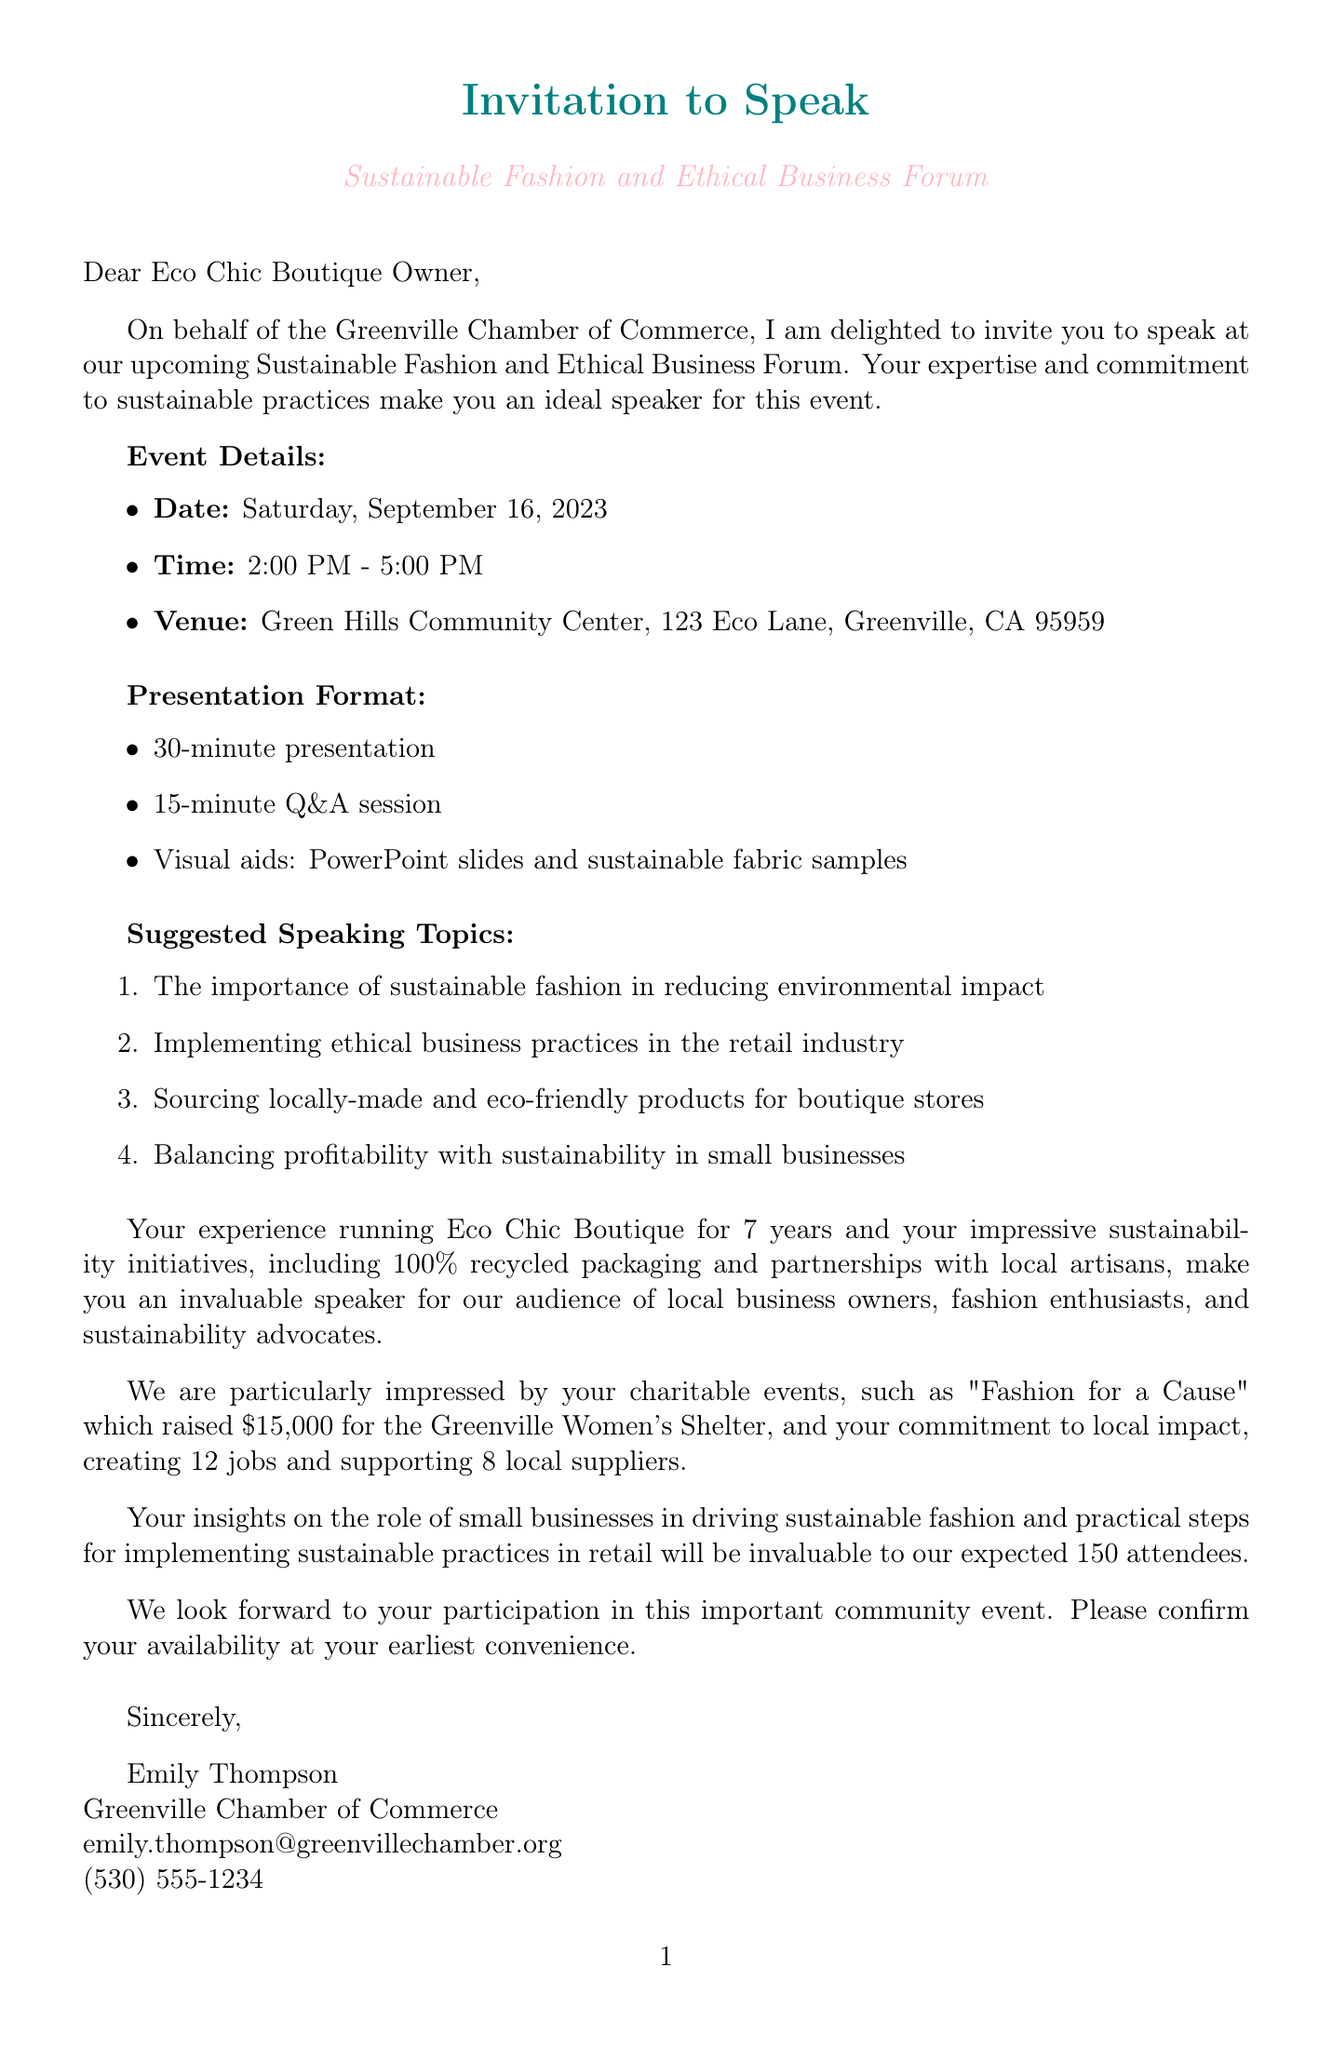What is the name of the event? The name of the event is mentioned in the document’s title as "Sustainable Fashion and Ethical Business Forum."
Answer: Sustainable Fashion and Ethical Business Forum What is the date of the event? The date of the event is specified in the event details section.
Answer: Saturday, September 16, 2023 Who is the contact person for the event? The document states that the contact person is Emily Thompson, who is associated with the organizing body.
Answer: Emily Thompson How long is the presentation? The presentation duration is mentioned in the presentation format section of the document.
Answer: 30-minute How much funds were raised for the "Fashion for a Cause"? The document provides information about the funds raised for specific charitable events, including this one.
Answer: $15,000 What is one of the suggested speaking topics? The document lists suggested speaking topics for the presentation; any of them would be a valid answer.
Answer: The importance of sustainable fashion in reducing environmental impact What is the anticipated number of attendees? The expected attendees are mentioned in the audience section of the document.
Answer: 150 How many years has Eco Chic Boutique been in business? The number of years Eco Chic Boutique has been in business is provided in the boutique credentials section.
Answer: 7 What organization is hosting the event? The organizing body is specifically mentioned in the document as the host of the event.
Answer: Greenville Chamber of Commerce 